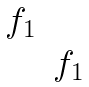<formula> <loc_0><loc_0><loc_500><loc_500>\begin{matrix} f _ { 1 } & \\ & f _ { 1 } \end{matrix}</formula> 